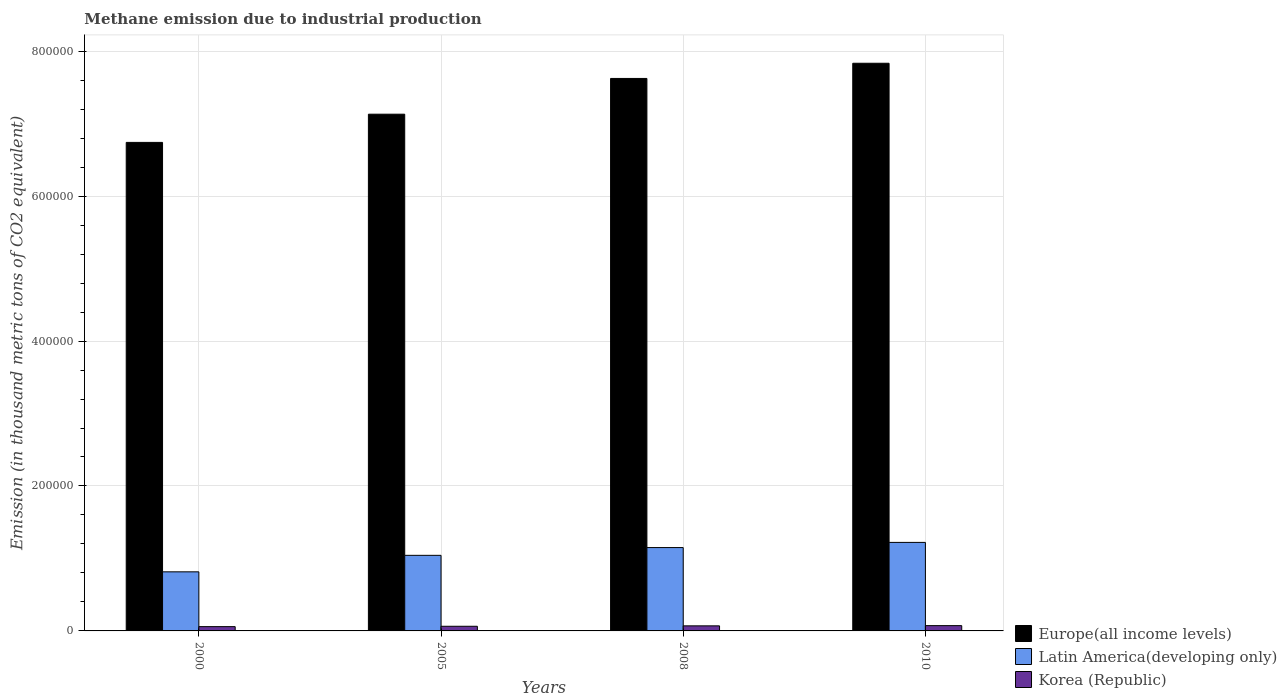How many groups of bars are there?
Give a very brief answer. 4. Are the number of bars on each tick of the X-axis equal?
Keep it short and to the point. Yes. How many bars are there on the 4th tick from the left?
Provide a succinct answer. 3. How many bars are there on the 2nd tick from the right?
Provide a short and direct response. 3. What is the label of the 3rd group of bars from the left?
Provide a short and direct response. 2008. In how many cases, is the number of bars for a given year not equal to the number of legend labels?
Your answer should be very brief. 0. What is the amount of methane emitted in Latin America(developing only) in 2010?
Your response must be concise. 1.22e+05. Across all years, what is the maximum amount of methane emitted in Europe(all income levels)?
Provide a short and direct response. 7.83e+05. Across all years, what is the minimum amount of methane emitted in Europe(all income levels)?
Provide a short and direct response. 6.74e+05. In which year was the amount of methane emitted in Europe(all income levels) minimum?
Your response must be concise. 2000. What is the total amount of methane emitted in Korea (Republic) in the graph?
Keep it short and to the point. 2.66e+04. What is the difference between the amount of methane emitted in Korea (Republic) in 2005 and that in 2010?
Provide a short and direct response. -890.8. What is the difference between the amount of methane emitted in Latin America(developing only) in 2008 and the amount of methane emitted in Europe(all income levels) in 2010?
Your answer should be compact. -6.68e+05. What is the average amount of methane emitted in Korea (Republic) per year?
Offer a very short reply. 6653.78. In the year 2005, what is the difference between the amount of methane emitted in Korea (Republic) and amount of methane emitted in Latin America(developing only)?
Provide a succinct answer. -9.79e+04. In how many years, is the amount of methane emitted in Korea (Republic) greater than 520000 thousand metric tons?
Give a very brief answer. 0. What is the ratio of the amount of methane emitted in Europe(all income levels) in 2005 to that in 2010?
Offer a very short reply. 0.91. Is the difference between the amount of methane emitted in Korea (Republic) in 2000 and 2005 greater than the difference between the amount of methane emitted in Latin America(developing only) in 2000 and 2005?
Keep it short and to the point. Yes. What is the difference between the highest and the second highest amount of methane emitted in Europe(all income levels)?
Offer a very short reply. 2.10e+04. What is the difference between the highest and the lowest amount of methane emitted in Korea (Republic)?
Offer a very short reply. 1388.4. What does the 1st bar from the left in 2005 represents?
Offer a very short reply. Europe(all income levels). What does the 2nd bar from the right in 2008 represents?
Your answer should be very brief. Latin America(developing only). How many bars are there?
Keep it short and to the point. 12. Are all the bars in the graph horizontal?
Make the answer very short. No. Are the values on the major ticks of Y-axis written in scientific E-notation?
Make the answer very short. No. Does the graph contain any zero values?
Provide a succinct answer. No. Where does the legend appear in the graph?
Provide a short and direct response. Bottom right. How many legend labels are there?
Offer a very short reply. 3. What is the title of the graph?
Provide a short and direct response. Methane emission due to industrial production. What is the label or title of the Y-axis?
Give a very brief answer. Emission (in thousand metric tons of CO2 equivalent). What is the Emission (in thousand metric tons of CO2 equivalent) in Europe(all income levels) in 2000?
Offer a terse response. 6.74e+05. What is the Emission (in thousand metric tons of CO2 equivalent) in Latin America(developing only) in 2000?
Provide a short and direct response. 8.15e+04. What is the Emission (in thousand metric tons of CO2 equivalent) of Korea (Republic) in 2000?
Provide a short and direct response. 5912.8. What is the Emission (in thousand metric tons of CO2 equivalent) in Europe(all income levels) in 2005?
Make the answer very short. 7.13e+05. What is the Emission (in thousand metric tons of CO2 equivalent) of Latin America(developing only) in 2005?
Your answer should be very brief. 1.04e+05. What is the Emission (in thousand metric tons of CO2 equivalent) in Korea (Republic) in 2005?
Your answer should be compact. 6410.4. What is the Emission (in thousand metric tons of CO2 equivalent) in Europe(all income levels) in 2008?
Offer a terse response. 7.62e+05. What is the Emission (in thousand metric tons of CO2 equivalent) of Latin America(developing only) in 2008?
Your answer should be very brief. 1.15e+05. What is the Emission (in thousand metric tons of CO2 equivalent) of Korea (Republic) in 2008?
Offer a terse response. 6990.7. What is the Emission (in thousand metric tons of CO2 equivalent) of Europe(all income levels) in 2010?
Keep it short and to the point. 7.83e+05. What is the Emission (in thousand metric tons of CO2 equivalent) of Latin America(developing only) in 2010?
Keep it short and to the point. 1.22e+05. What is the Emission (in thousand metric tons of CO2 equivalent) in Korea (Republic) in 2010?
Your response must be concise. 7301.2. Across all years, what is the maximum Emission (in thousand metric tons of CO2 equivalent) in Europe(all income levels)?
Your response must be concise. 7.83e+05. Across all years, what is the maximum Emission (in thousand metric tons of CO2 equivalent) in Latin America(developing only)?
Offer a very short reply. 1.22e+05. Across all years, what is the maximum Emission (in thousand metric tons of CO2 equivalent) in Korea (Republic)?
Your response must be concise. 7301.2. Across all years, what is the minimum Emission (in thousand metric tons of CO2 equivalent) of Europe(all income levels)?
Your answer should be very brief. 6.74e+05. Across all years, what is the minimum Emission (in thousand metric tons of CO2 equivalent) in Latin America(developing only)?
Your response must be concise. 8.15e+04. Across all years, what is the minimum Emission (in thousand metric tons of CO2 equivalent) in Korea (Republic)?
Your answer should be compact. 5912.8. What is the total Emission (in thousand metric tons of CO2 equivalent) of Europe(all income levels) in the graph?
Your response must be concise. 2.93e+06. What is the total Emission (in thousand metric tons of CO2 equivalent) of Latin America(developing only) in the graph?
Provide a short and direct response. 4.23e+05. What is the total Emission (in thousand metric tons of CO2 equivalent) in Korea (Republic) in the graph?
Provide a succinct answer. 2.66e+04. What is the difference between the Emission (in thousand metric tons of CO2 equivalent) of Europe(all income levels) in 2000 and that in 2005?
Make the answer very short. -3.89e+04. What is the difference between the Emission (in thousand metric tons of CO2 equivalent) of Latin America(developing only) in 2000 and that in 2005?
Give a very brief answer. -2.28e+04. What is the difference between the Emission (in thousand metric tons of CO2 equivalent) of Korea (Republic) in 2000 and that in 2005?
Your answer should be very brief. -497.6. What is the difference between the Emission (in thousand metric tons of CO2 equivalent) in Europe(all income levels) in 2000 and that in 2008?
Keep it short and to the point. -8.82e+04. What is the difference between the Emission (in thousand metric tons of CO2 equivalent) of Latin America(developing only) in 2000 and that in 2008?
Keep it short and to the point. -3.35e+04. What is the difference between the Emission (in thousand metric tons of CO2 equivalent) of Korea (Republic) in 2000 and that in 2008?
Provide a succinct answer. -1077.9. What is the difference between the Emission (in thousand metric tons of CO2 equivalent) of Europe(all income levels) in 2000 and that in 2010?
Your answer should be compact. -1.09e+05. What is the difference between the Emission (in thousand metric tons of CO2 equivalent) in Latin America(developing only) in 2000 and that in 2010?
Ensure brevity in your answer.  -4.06e+04. What is the difference between the Emission (in thousand metric tons of CO2 equivalent) of Korea (Republic) in 2000 and that in 2010?
Ensure brevity in your answer.  -1388.4. What is the difference between the Emission (in thousand metric tons of CO2 equivalent) in Europe(all income levels) in 2005 and that in 2008?
Your answer should be compact. -4.93e+04. What is the difference between the Emission (in thousand metric tons of CO2 equivalent) in Latin America(developing only) in 2005 and that in 2008?
Your answer should be very brief. -1.07e+04. What is the difference between the Emission (in thousand metric tons of CO2 equivalent) of Korea (Republic) in 2005 and that in 2008?
Provide a short and direct response. -580.3. What is the difference between the Emission (in thousand metric tons of CO2 equivalent) of Europe(all income levels) in 2005 and that in 2010?
Offer a terse response. -7.03e+04. What is the difference between the Emission (in thousand metric tons of CO2 equivalent) of Latin America(developing only) in 2005 and that in 2010?
Your answer should be very brief. -1.79e+04. What is the difference between the Emission (in thousand metric tons of CO2 equivalent) in Korea (Republic) in 2005 and that in 2010?
Keep it short and to the point. -890.8. What is the difference between the Emission (in thousand metric tons of CO2 equivalent) of Europe(all income levels) in 2008 and that in 2010?
Offer a very short reply. -2.10e+04. What is the difference between the Emission (in thousand metric tons of CO2 equivalent) of Latin America(developing only) in 2008 and that in 2010?
Ensure brevity in your answer.  -7129.8. What is the difference between the Emission (in thousand metric tons of CO2 equivalent) in Korea (Republic) in 2008 and that in 2010?
Provide a short and direct response. -310.5. What is the difference between the Emission (in thousand metric tons of CO2 equivalent) in Europe(all income levels) in 2000 and the Emission (in thousand metric tons of CO2 equivalent) in Latin America(developing only) in 2005?
Offer a very short reply. 5.70e+05. What is the difference between the Emission (in thousand metric tons of CO2 equivalent) in Europe(all income levels) in 2000 and the Emission (in thousand metric tons of CO2 equivalent) in Korea (Republic) in 2005?
Keep it short and to the point. 6.68e+05. What is the difference between the Emission (in thousand metric tons of CO2 equivalent) of Latin America(developing only) in 2000 and the Emission (in thousand metric tons of CO2 equivalent) of Korea (Republic) in 2005?
Your answer should be compact. 7.51e+04. What is the difference between the Emission (in thousand metric tons of CO2 equivalent) in Europe(all income levels) in 2000 and the Emission (in thousand metric tons of CO2 equivalent) in Latin America(developing only) in 2008?
Your response must be concise. 5.59e+05. What is the difference between the Emission (in thousand metric tons of CO2 equivalent) in Europe(all income levels) in 2000 and the Emission (in thousand metric tons of CO2 equivalent) in Korea (Republic) in 2008?
Offer a terse response. 6.67e+05. What is the difference between the Emission (in thousand metric tons of CO2 equivalent) in Latin America(developing only) in 2000 and the Emission (in thousand metric tons of CO2 equivalent) in Korea (Republic) in 2008?
Your answer should be very brief. 7.45e+04. What is the difference between the Emission (in thousand metric tons of CO2 equivalent) of Europe(all income levels) in 2000 and the Emission (in thousand metric tons of CO2 equivalent) of Latin America(developing only) in 2010?
Ensure brevity in your answer.  5.52e+05. What is the difference between the Emission (in thousand metric tons of CO2 equivalent) in Europe(all income levels) in 2000 and the Emission (in thousand metric tons of CO2 equivalent) in Korea (Republic) in 2010?
Ensure brevity in your answer.  6.67e+05. What is the difference between the Emission (in thousand metric tons of CO2 equivalent) of Latin America(developing only) in 2000 and the Emission (in thousand metric tons of CO2 equivalent) of Korea (Republic) in 2010?
Provide a succinct answer. 7.42e+04. What is the difference between the Emission (in thousand metric tons of CO2 equivalent) of Europe(all income levels) in 2005 and the Emission (in thousand metric tons of CO2 equivalent) of Latin America(developing only) in 2008?
Provide a succinct answer. 5.98e+05. What is the difference between the Emission (in thousand metric tons of CO2 equivalent) of Europe(all income levels) in 2005 and the Emission (in thousand metric tons of CO2 equivalent) of Korea (Republic) in 2008?
Your response must be concise. 7.06e+05. What is the difference between the Emission (in thousand metric tons of CO2 equivalent) in Latin America(developing only) in 2005 and the Emission (in thousand metric tons of CO2 equivalent) in Korea (Republic) in 2008?
Keep it short and to the point. 9.73e+04. What is the difference between the Emission (in thousand metric tons of CO2 equivalent) in Europe(all income levels) in 2005 and the Emission (in thousand metric tons of CO2 equivalent) in Latin America(developing only) in 2010?
Offer a terse response. 5.91e+05. What is the difference between the Emission (in thousand metric tons of CO2 equivalent) of Europe(all income levels) in 2005 and the Emission (in thousand metric tons of CO2 equivalent) of Korea (Republic) in 2010?
Offer a very short reply. 7.06e+05. What is the difference between the Emission (in thousand metric tons of CO2 equivalent) in Latin America(developing only) in 2005 and the Emission (in thousand metric tons of CO2 equivalent) in Korea (Republic) in 2010?
Offer a terse response. 9.70e+04. What is the difference between the Emission (in thousand metric tons of CO2 equivalent) in Europe(all income levels) in 2008 and the Emission (in thousand metric tons of CO2 equivalent) in Latin America(developing only) in 2010?
Offer a terse response. 6.40e+05. What is the difference between the Emission (in thousand metric tons of CO2 equivalent) of Europe(all income levels) in 2008 and the Emission (in thousand metric tons of CO2 equivalent) of Korea (Republic) in 2010?
Ensure brevity in your answer.  7.55e+05. What is the difference between the Emission (in thousand metric tons of CO2 equivalent) of Latin America(developing only) in 2008 and the Emission (in thousand metric tons of CO2 equivalent) of Korea (Republic) in 2010?
Ensure brevity in your answer.  1.08e+05. What is the average Emission (in thousand metric tons of CO2 equivalent) of Europe(all income levels) per year?
Your answer should be very brief. 7.33e+05. What is the average Emission (in thousand metric tons of CO2 equivalent) of Latin America(developing only) per year?
Provide a short and direct response. 1.06e+05. What is the average Emission (in thousand metric tons of CO2 equivalent) in Korea (Republic) per year?
Ensure brevity in your answer.  6653.77. In the year 2000, what is the difference between the Emission (in thousand metric tons of CO2 equivalent) of Europe(all income levels) and Emission (in thousand metric tons of CO2 equivalent) of Latin America(developing only)?
Provide a succinct answer. 5.93e+05. In the year 2000, what is the difference between the Emission (in thousand metric tons of CO2 equivalent) in Europe(all income levels) and Emission (in thousand metric tons of CO2 equivalent) in Korea (Republic)?
Give a very brief answer. 6.68e+05. In the year 2000, what is the difference between the Emission (in thousand metric tons of CO2 equivalent) of Latin America(developing only) and Emission (in thousand metric tons of CO2 equivalent) of Korea (Republic)?
Keep it short and to the point. 7.56e+04. In the year 2005, what is the difference between the Emission (in thousand metric tons of CO2 equivalent) of Europe(all income levels) and Emission (in thousand metric tons of CO2 equivalent) of Latin America(developing only)?
Offer a very short reply. 6.09e+05. In the year 2005, what is the difference between the Emission (in thousand metric tons of CO2 equivalent) of Europe(all income levels) and Emission (in thousand metric tons of CO2 equivalent) of Korea (Republic)?
Offer a very short reply. 7.07e+05. In the year 2005, what is the difference between the Emission (in thousand metric tons of CO2 equivalent) of Latin America(developing only) and Emission (in thousand metric tons of CO2 equivalent) of Korea (Republic)?
Your response must be concise. 9.79e+04. In the year 2008, what is the difference between the Emission (in thousand metric tons of CO2 equivalent) of Europe(all income levels) and Emission (in thousand metric tons of CO2 equivalent) of Latin America(developing only)?
Your answer should be compact. 6.47e+05. In the year 2008, what is the difference between the Emission (in thousand metric tons of CO2 equivalent) of Europe(all income levels) and Emission (in thousand metric tons of CO2 equivalent) of Korea (Republic)?
Offer a terse response. 7.55e+05. In the year 2008, what is the difference between the Emission (in thousand metric tons of CO2 equivalent) in Latin America(developing only) and Emission (in thousand metric tons of CO2 equivalent) in Korea (Republic)?
Offer a very short reply. 1.08e+05. In the year 2010, what is the difference between the Emission (in thousand metric tons of CO2 equivalent) in Europe(all income levels) and Emission (in thousand metric tons of CO2 equivalent) in Latin America(developing only)?
Your answer should be compact. 6.61e+05. In the year 2010, what is the difference between the Emission (in thousand metric tons of CO2 equivalent) in Europe(all income levels) and Emission (in thousand metric tons of CO2 equivalent) in Korea (Republic)?
Give a very brief answer. 7.76e+05. In the year 2010, what is the difference between the Emission (in thousand metric tons of CO2 equivalent) in Latin America(developing only) and Emission (in thousand metric tons of CO2 equivalent) in Korea (Republic)?
Your answer should be very brief. 1.15e+05. What is the ratio of the Emission (in thousand metric tons of CO2 equivalent) in Europe(all income levels) in 2000 to that in 2005?
Make the answer very short. 0.95. What is the ratio of the Emission (in thousand metric tons of CO2 equivalent) in Latin America(developing only) in 2000 to that in 2005?
Offer a terse response. 0.78. What is the ratio of the Emission (in thousand metric tons of CO2 equivalent) of Korea (Republic) in 2000 to that in 2005?
Give a very brief answer. 0.92. What is the ratio of the Emission (in thousand metric tons of CO2 equivalent) of Europe(all income levels) in 2000 to that in 2008?
Provide a short and direct response. 0.88. What is the ratio of the Emission (in thousand metric tons of CO2 equivalent) in Latin America(developing only) in 2000 to that in 2008?
Provide a succinct answer. 0.71. What is the ratio of the Emission (in thousand metric tons of CO2 equivalent) of Korea (Republic) in 2000 to that in 2008?
Your answer should be compact. 0.85. What is the ratio of the Emission (in thousand metric tons of CO2 equivalent) in Europe(all income levels) in 2000 to that in 2010?
Offer a very short reply. 0.86. What is the ratio of the Emission (in thousand metric tons of CO2 equivalent) in Latin America(developing only) in 2000 to that in 2010?
Make the answer very short. 0.67. What is the ratio of the Emission (in thousand metric tons of CO2 equivalent) of Korea (Republic) in 2000 to that in 2010?
Your response must be concise. 0.81. What is the ratio of the Emission (in thousand metric tons of CO2 equivalent) in Europe(all income levels) in 2005 to that in 2008?
Make the answer very short. 0.94. What is the ratio of the Emission (in thousand metric tons of CO2 equivalent) of Latin America(developing only) in 2005 to that in 2008?
Your response must be concise. 0.91. What is the ratio of the Emission (in thousand metric tons of CO2 equivalent) of Korea (Republic) in 2005 to that in 2008?
Make the answer very short. 0.92. What is the ratio of the Emission (in thousand metric tons of CO2 equivalent) in Europe(all income levels) in 2005 to that in 2010?
Your answer should be very brief. 0.91. What is the ratio of the Emission (in thousand metric tons of CO2 equivalent) of Latin America(developing only) in 2005 to that in 2010?
Make the answer very short. 0.85. What is the ratio of the Emission (in thousand metric tons of CO2 equivalent) of Korea (Republic) in 2005 to that in 2010?
Your response must be concise. 0.88. What is the ratio of the Emission (in thousand metric tons of CO2 equivalent) in Europe(all income levels) in 2008 to that in 2010?
Your answer should be compact. 0.97. What is the ratio of the Emission (in thousand metric tons of CO2 equivalent) of Latin America(developing only) in 2008 to that in 2010?
Give a very brief answer. 0.94. What is the ratio of the Emission (in thousand metric tons of CO2 equivalent) in Korea (Republic) in 2008 to that in 2010?
Make the answer very short. 0.96. What is the difference between the highest and the second highest Emission (in thousand metric tons of CO2 equivalent) in Europe(all income levels)?
Provide a succinct answer. 2.10e+04. What is the difference between the highest and the second highest Emission (in thousand metric tons of CO2 equivalent) of Latin America(developing only)?
Ensure brevity in your answer.  7129.8. What is the difference between the highest and the second highest Emission (in thousand metric tons of CO2 equivalent) of Korea (Republic)?
Make the answer very short. 310.5. What is the difference between the highest and the lowest Emission (in thousand metric tons of CO2 equivalent) of Europe(all income levels)?
Provide a succinct answer. 1.09e+05. What is the difference between the highest and the lowest Emission (in thousand metric tons of CO2 equivalent) of Latin America(developing only)?
Keep it short and to the point. 4.06e+04. What is the difference between the highest and the lowest Emission (in thousand metric tons of CO2 equivalent) of Korea (Republic)?
Ensure brevity in your answer.  1388.4. 